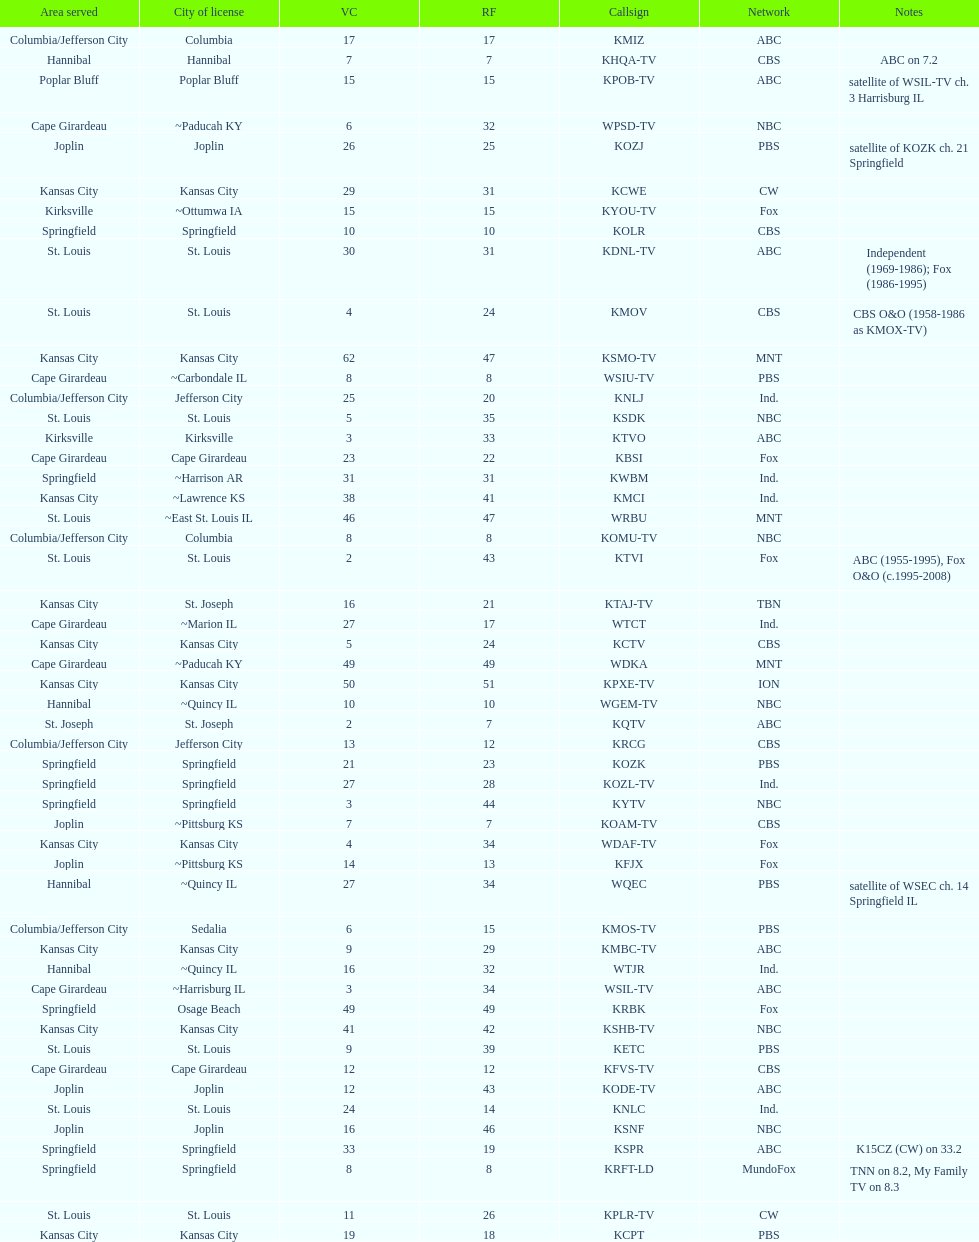What is the overall quantity of stations belonging to the cbs network? 7. 